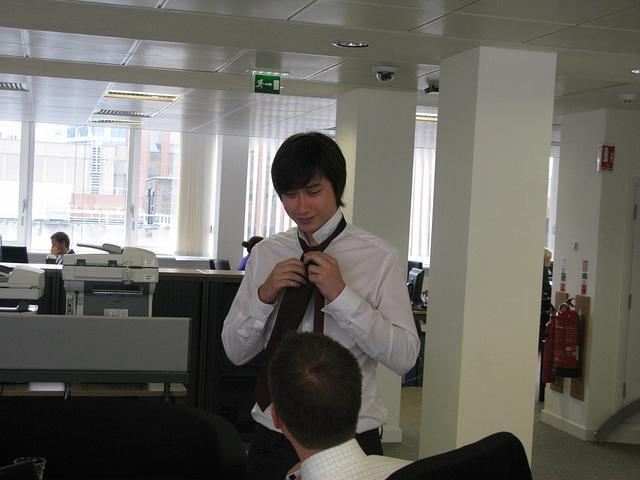How many people are there?
Give a very brief answer. 2. 